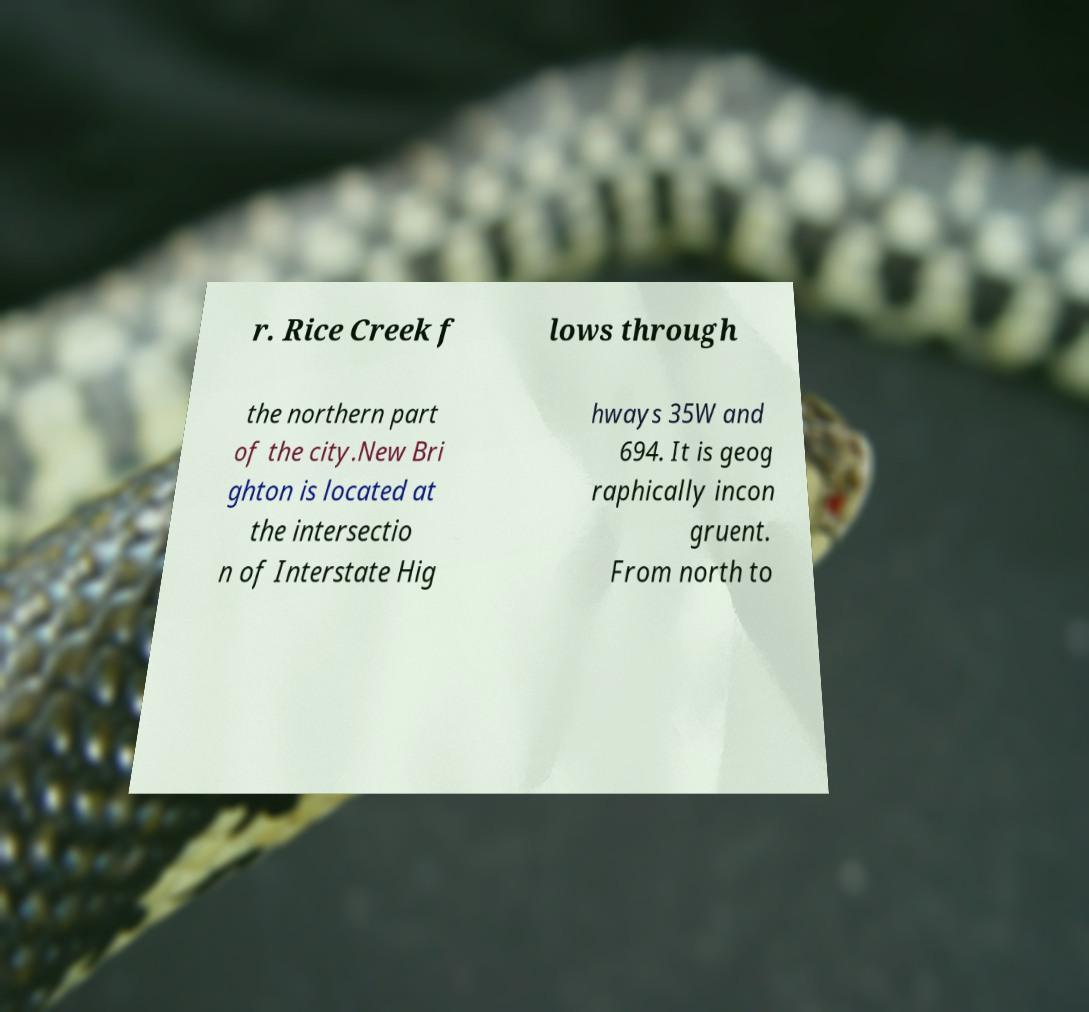Please read and relay the text visible in this image. What does it say? r. Rice Creek f lows through the northern part of the city.New Bri ghton is located at the intersectio n of Interstate Hig hways 35W and 694. It is geog raphically incon gruent. From north to 